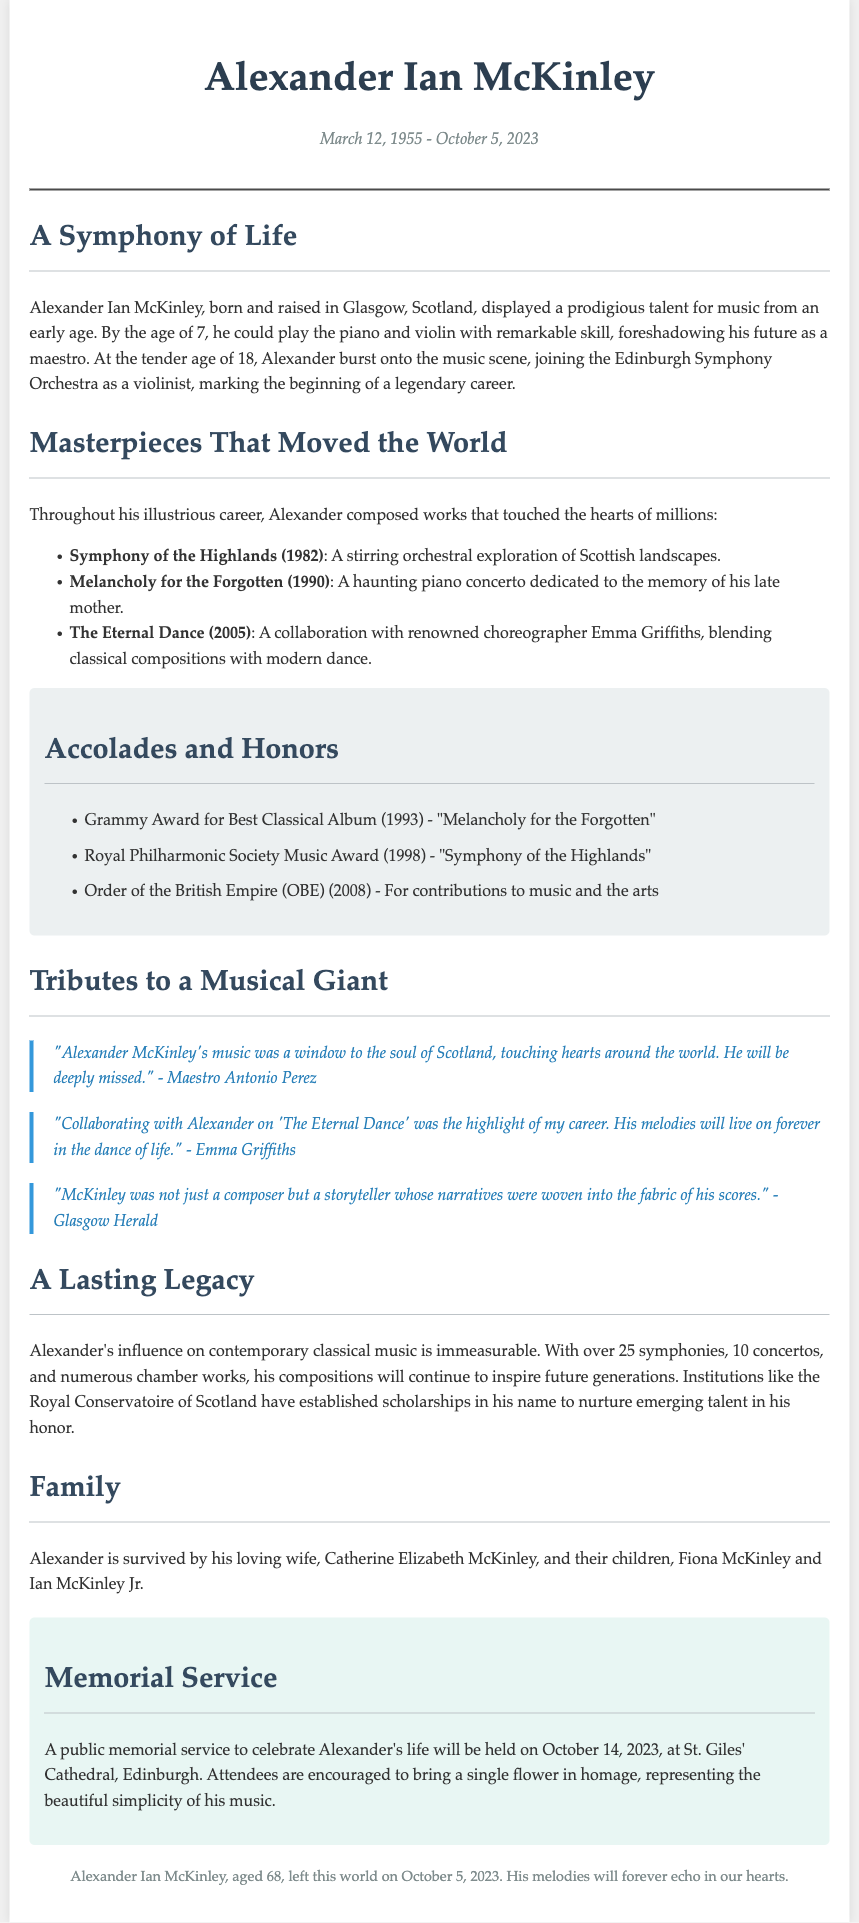What is the full name of the musician? The full name of the musician is mentioned in the header of the document.
Answer: Alexander Ian McKinley When was Alexander Ian McKinley born? The date of birth for Alexander is provided in the document.
Answer: March 12, 1955 What notable award did he receive in 1993? The document lists the awards he received, including the Grammy Award for Best Classical Album.
Answer: Grammy Award for Best Classical Album How many children did Alexander have? The document states the number of children he is survived by.
Answer: Two Which orchestra did he join at age 18? The document specifies the orchestra he joined at this age.
Answer: Edinburgh Symphony Orchestra What is the title of his 1982 work? The document provides the names of his compositions, which includes a specific title from 1982.
Answer: Symphony of the Highlands What significant event will occur on October 14, 2023? The document mentions a specific event related to his memory.
Answer: Public memorial service What is the name of his wife? The document states the name of Alexander's wife in the family section.
Answer: Catherine Elizabeth McKinley Who collaborated with Alexander on "The Eternal Dance"? The document cites a specific individual he collaborated with for this work.
Answer: Emma Griffiths 